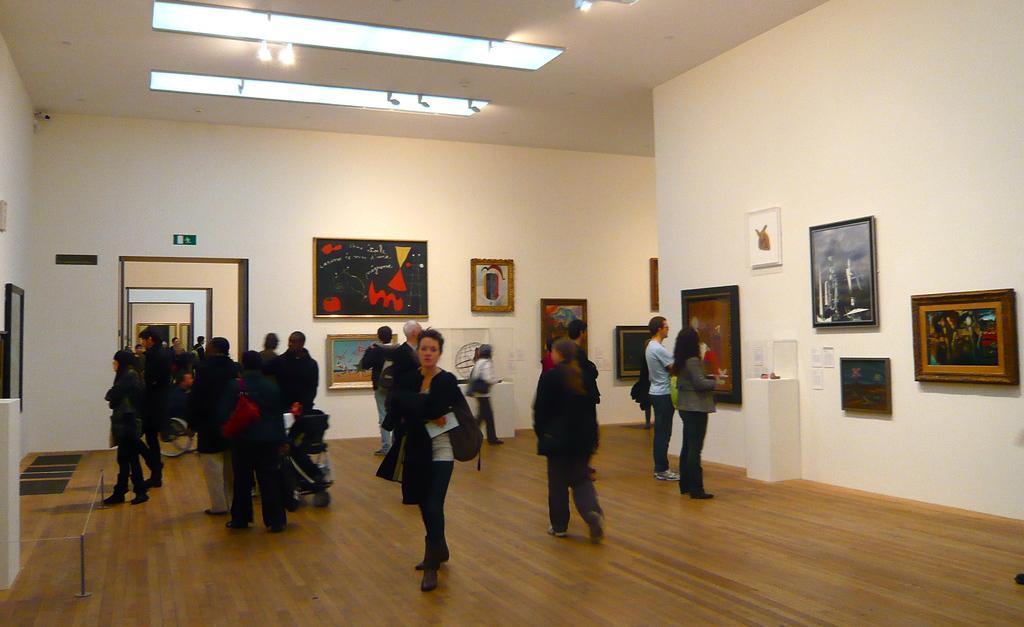How would you summarize this image in a sentence or two? In this image we can see these people are walking on the wooden floor and we can see photo frames on the wall. In the background, we can see another room in which people are walking and photo frames are kept on the wall and also we can see lights to the ceiling. 